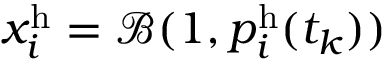Convert formula to latex. <formula><loc_0><loc_0><loc_500><loc_500>x _ { i } ^ { h } = \mathcal { B } ( 1 , p _ { i } ^ { h } ( t _ { k } ) )</formula> 